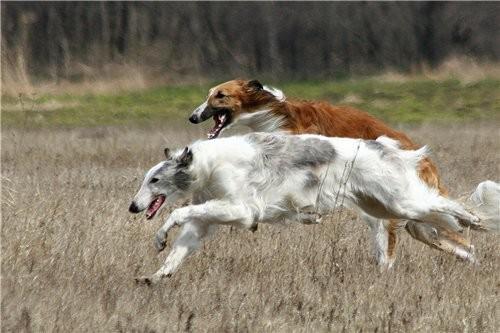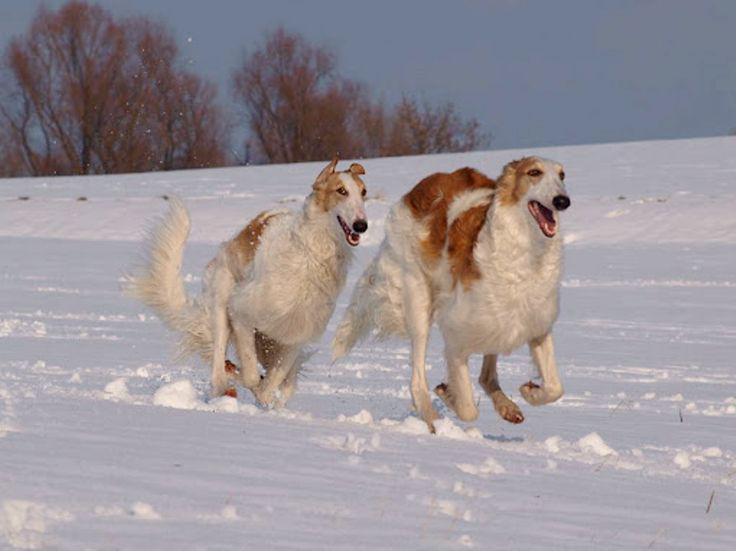The first image is the image on the left, the second image is the image on the right. Analyze the images presented: Is the assertion "One image shows two hounds with similar coloration." valid? Answer yes or no. Yes. 